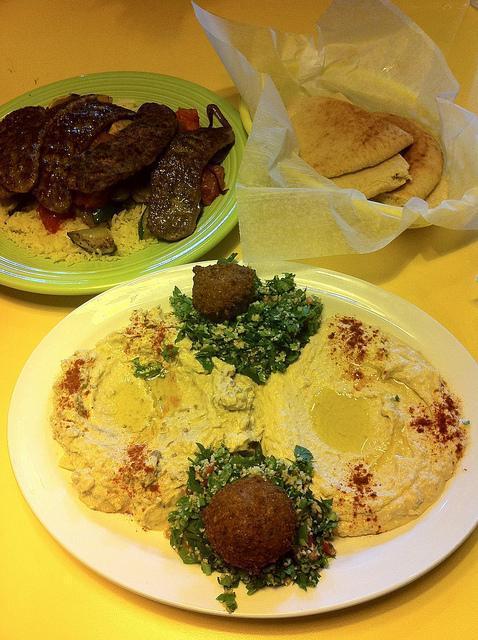How many dark brown sheep are in the image?
Give a very brief answer. 0. 